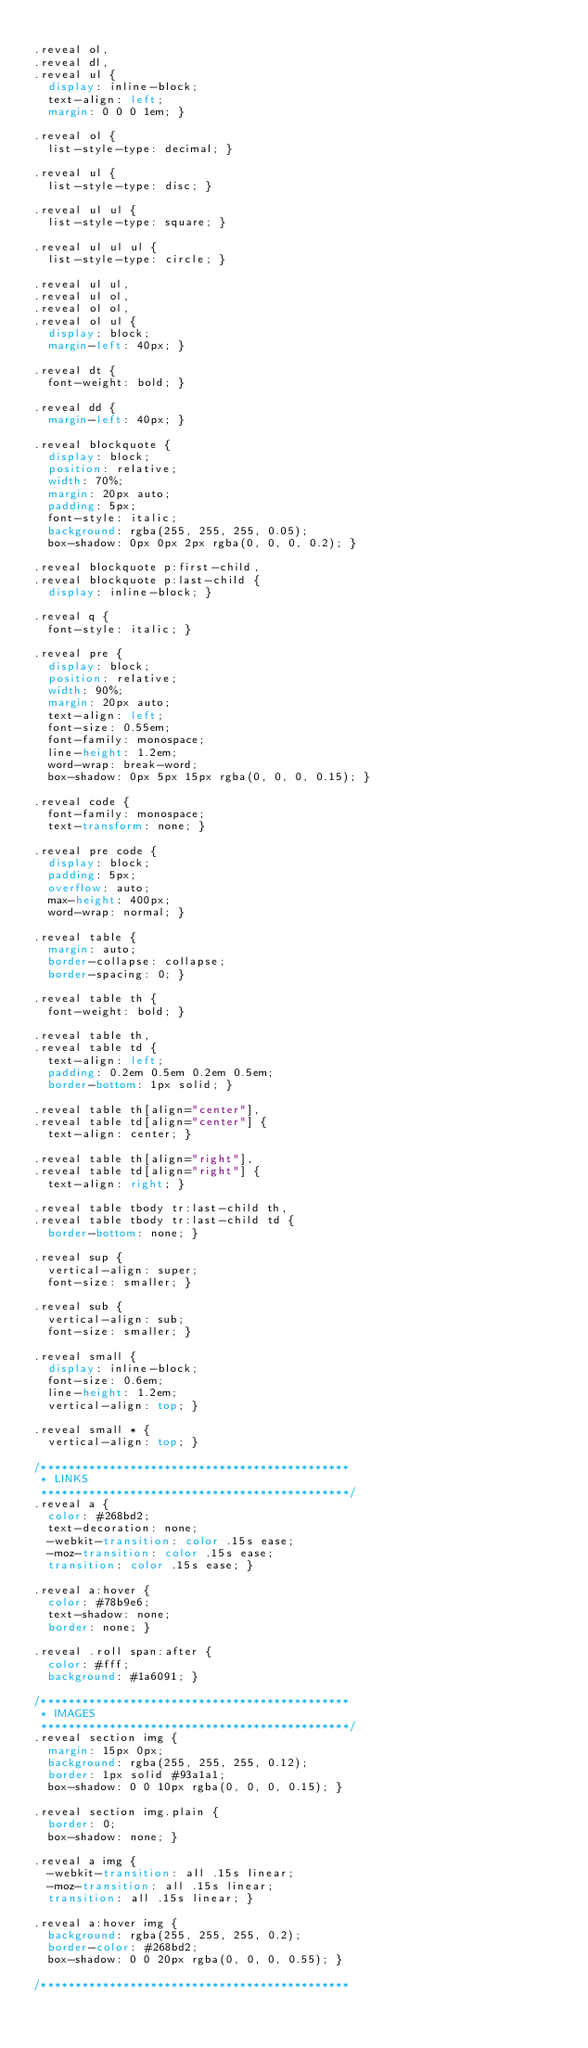<code> <loc_0><loc_0><loc_500><loc_500><_CSS_>
.reveal ol,
.reveal dl,
.reveal ul {
  display: inline-block;
  text-align: left;
  margin: 0 0 0 1em; }

.reveal ol {
  list-style-type: decimal; }

.reveal ul {
  list-style-type: disc; }

.reveal ul ul {
  list-style-type: square; }

.reveal ul ul ul {
  list-style-type: circle; }

.reveal ul ul,
.reveal ul ol,
.reveal ol ol,
.reveal ol ul {
  display: block;
  margin-left: 40px; }

.reveal dt {
  font-weight: bold; }

.reveal dd {
  margin-left: 40px; }

.reveal blockquote {
  display: block;
  position: relative;
  width: 70%;
  margin: 20px auto;
  padding: 5px;
  font-style: italic;
  background: rgba(255, 255, 255, 0.05);
  box-shadow: 0px 0px 2px rgba(0, 0, 0, 0.2); }

.reveal blockquote p:first-child,
.reveal blockquote p:last-child {
  display: inline-block; }

.reveal q {
  font-style: italic; }

.reveal pre {
  display: block;
  position: relative;
  width: 90%;
  margin: 20px auto;
  text-align: left;
  font-size: 0.55em;
  font-family: monospace;
  line-height: 1.2em;
  word-wrap: break-word;
  box-shadow: 0px 5px 15px rgba(0, 0, 0, 0.15); }

.reveal code {
  font-family: monospace;
  text-transform: none; }

.reveal pre code {
  display: block;
  padding: 5px;
  overflow: auto;
  max-height: 400px;
  word-wrap: normal; }

.reveal table {
  margin: auto;
  border-collapse: collapse;
  border-spacing: 0; }

.reveal table th {
  font-weight: bold; }

.reveal table th,
.reveal table td {
  text-align: left;
  padding: 0.2em 0.5em 0.2em 0.5em;
  border-bottom: 1px solid; }

.reveal table th[align="center"],
.reveal table td[align="center"] {
  text-align: center; }

.reveal table th[align="right"],
.reveal table td[align="right"] {
  text-align: right; }

.reveal table tbody tr:last-child th,
.reveal table tbody tr:last-child td {
  border-bottom: none; }

.reveal sup {
  vertical-align: super;
  font-size: smaller; }

.reveal sub {
  vertical-align: sub;
  font-size: smaller; }

.reveal small {
  display: inline-block;
  font-size: 0.6em;
  line-height: 1.2em;
  vertical-align: top; }

.reveal small * {
  vertical-align: top; }

/*********************************************
 * LINKS
 *********************************************/
.reveal a {
  color: #268bd2;
  text-decoration: none;
  -webkit-transition: color .15s ease;
  -moz-transition: color .15s ease;
  transition: color .15s ease; }

.reveal a:hover {
  color: #78b9e6;
  text-shadow: none;
  border: none; }

.reveal .roll span:after {
  color: #fff;
  background: #1a6091; }

/*********************************************
 * IMAGES
 *********************************************/
.reveal section img {
  margin: 15px 0px;
  background: rgba(255, 255, 255, 0.12);
  border: 1px solid #93a1a1;
  box-shadow: 0 0 10px rgba(0, 0, 0, 0.15); }

.reveal section img.plain {
  border: 0;
  box-shadow: none; }

.reveal a img {
  -webkit-transition: all .15s linear;
  -moz-transition: all .15s linear;
  transition: all .15s linear; }

.reveal a:hover img {
  background: rgba(255, 255, 255, 0.2);
  border-color: #268bd2;
  box-shadow: 0 0 20px rgba(0, 0, 0, 0.55); }

/*********************************************</code> 